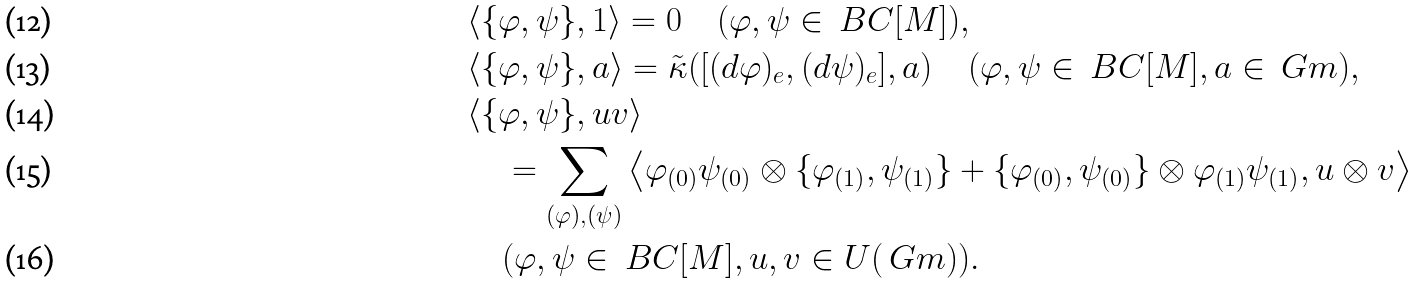<formula> <loc_0><loc_0><loc_500><loc_500>& \langle \{ \varphi , \psi \} , 1 \rangle = 0 \quad ( \varphi , \psi \in \ B C [ M ] ) , \\ & \langle \{ \varphi , \psi \} , a \rangle = \tilde { \kappa } ( [ ( d \varphi ) _ { e } , ( d \psi ) _ { e } ] , a ) \quad ( \varphi , \psi \in \ B C [ M ] , a \in \ G m ) , \\ & \langle \{ \varphi , \psi \} , u v \rangle \\ & \quad = \sum _ { ( \varphi ) , ( \psi ) } \left \langle \varphi _ { ( 0 ) } \psi _ { ( 0 ) } \otimes \{ \varphi _ { ( 1 ) } , \psi _ { ( 1 ) } \} + \{ \varphi _ { ( 0 ) } , \psi _ { ( 0 ) } \} \otimes \varphi _ { ( 1 ) } \psi _ { ( 1 ) } , u \otimes v \right \rangle \\ & \quad ( \varphi , \psi \in \ B C [ M ] , u , v \in U ( \ G m ) ) .</formula> 